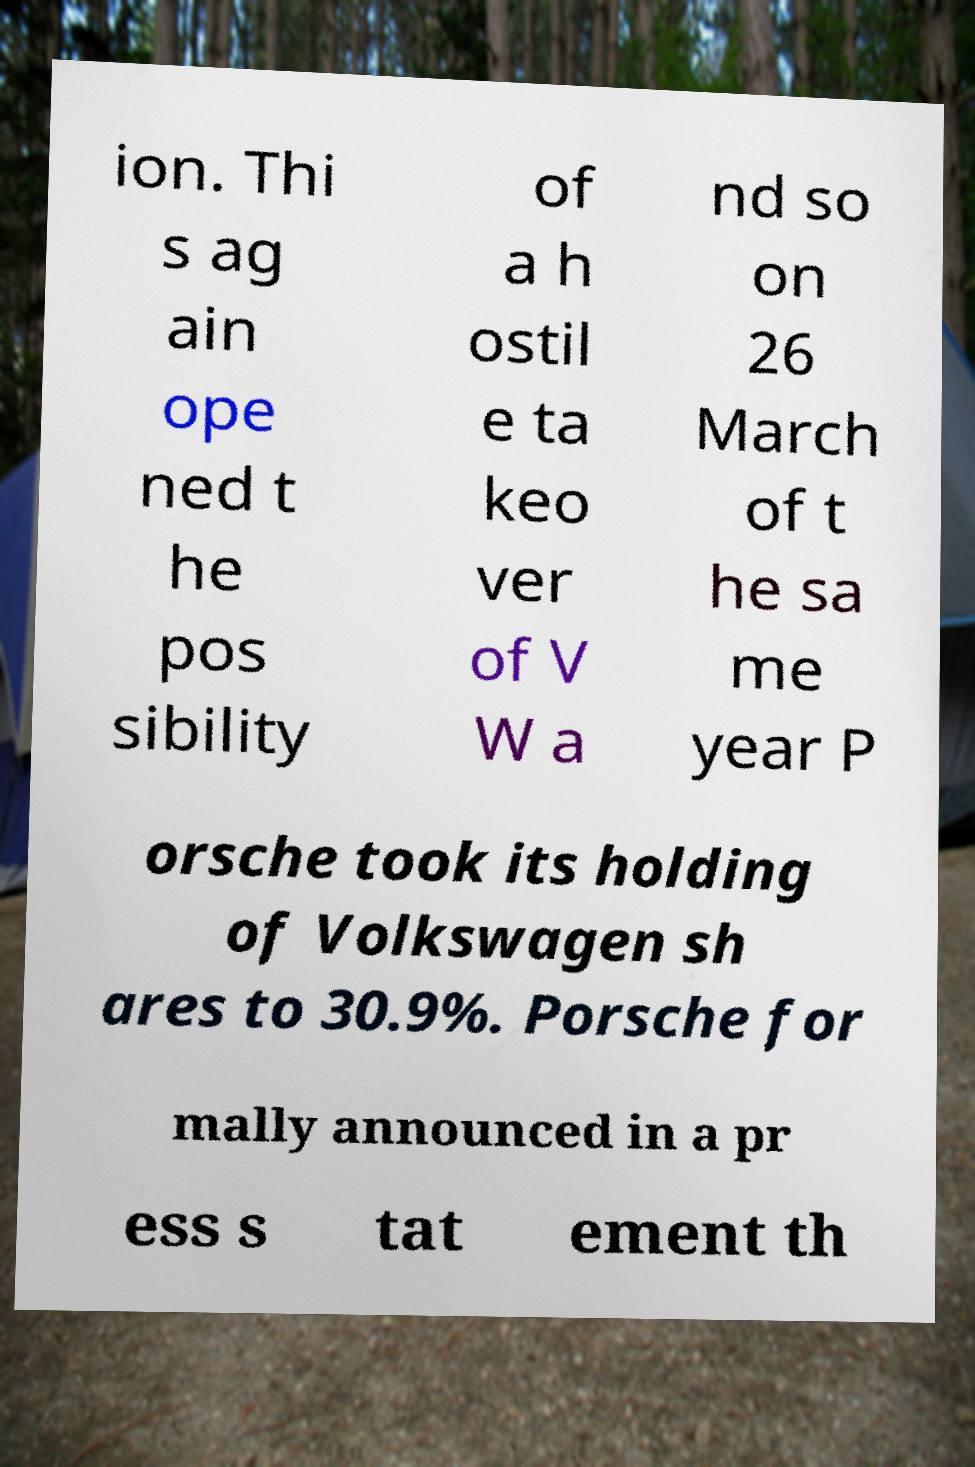Please read and relay the text visible in this image. What does it say? ion. Thi s ag ain ope ned t he pos sibility of a h ostil e ta keo ver of V W a nd so on 26 March of t he sa me year P orsche took its holding of Volkswagen sh ares to 30.9%. Porsche for mally announced in a pr ess s tat ement th 